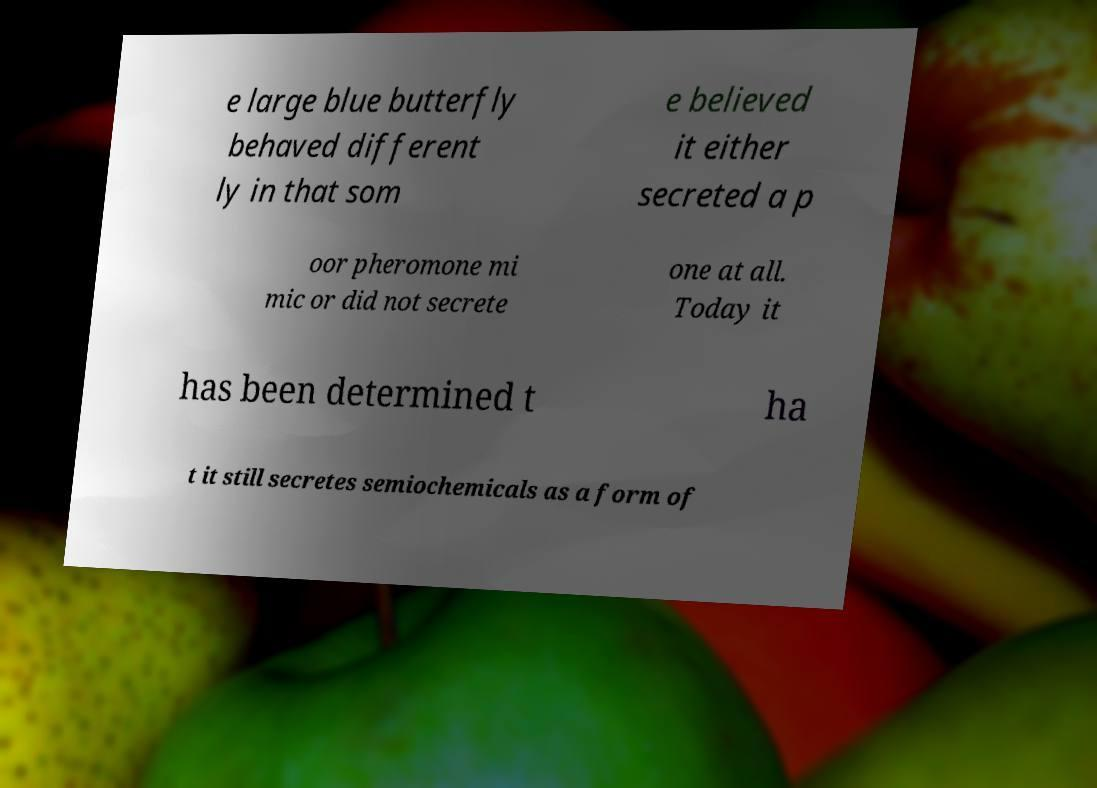Please identify and transcribe the text found in this image. e large blue butterfly behaved different ly in that som e believed it either secreted a p oor pheromone mi mic or did not secrete one at all. Today it has been determined t ha t it still secretes semiochemicals as a form of 